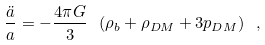<formula> <loc_0><loc_0><loc_500><loc_500>\frac { \ddot { a } } { a } = - \frac { 4 \pi G } { 3 } \ ( \rho _ { b } + \rho _ { D M } + 3 p _ { D M } ) \ ,</formula> 